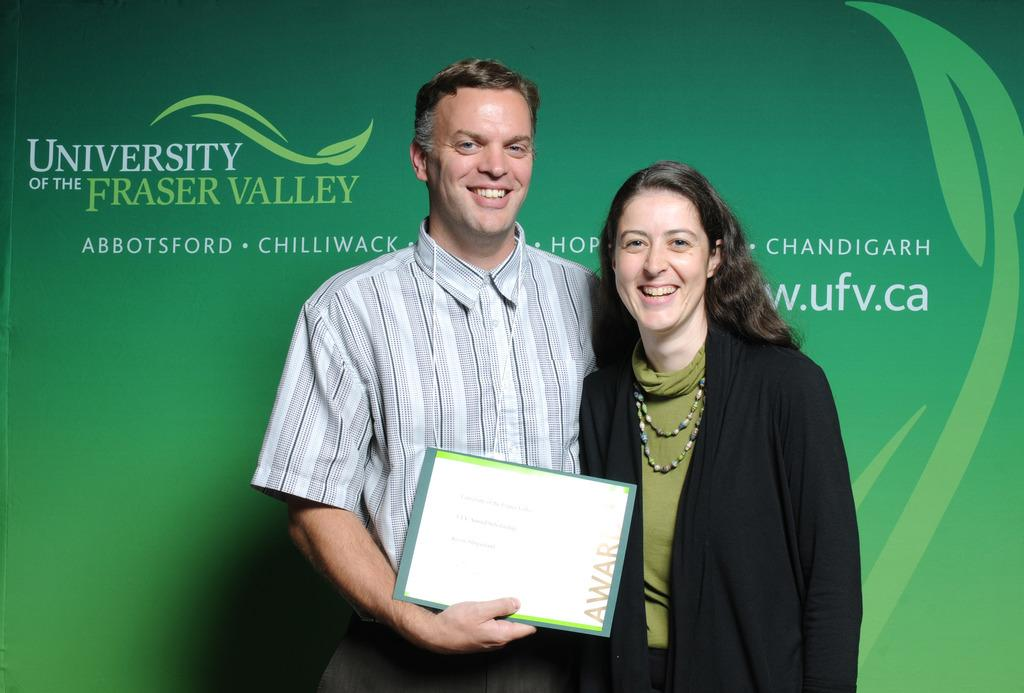How many people are in the image? There are two persons in the image. What are the persons holding in the image? Both persons are holding papers. What expressions do the persons have in the image? Both persons are smiling. Where is one of the persons located in the image? One person is standing in front of a wall. What can be seen on the wall in the image? There is text and a symbol on the wall. What type of soup is being served in the image? There is no soup present in the image. What type of juice is being consumed by the persons in the image? There is no juice present in the image. 